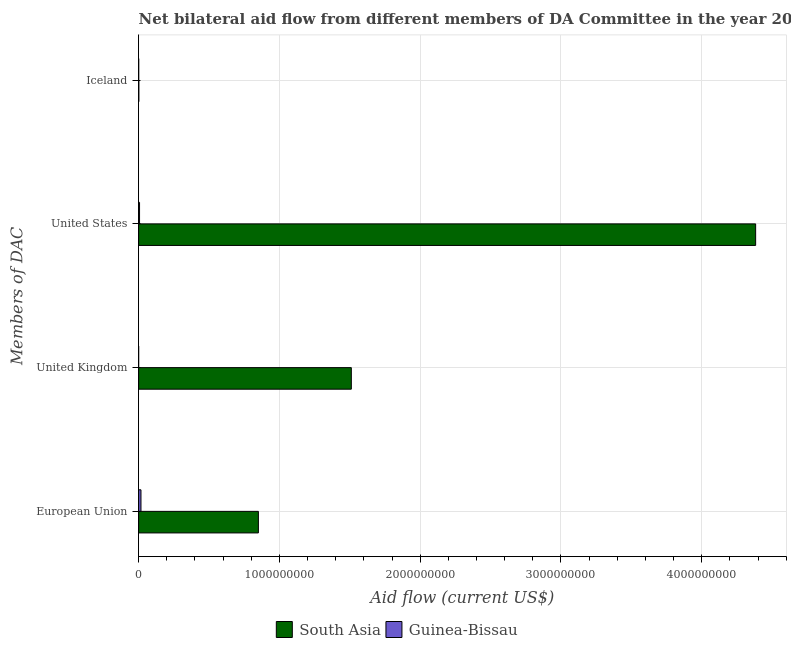How many different coloured bars are there?
Ensure brevity in your answer.  2. How many groups of bars are there?
Keep it short and to the point. 4. How many bars are there on the 1st tick from the top?
Keep it short and to the point. 2. What is the amount of aid given by us in South Asia?
Your answer should be compact. 4.38e+09. Across all countries, what is the maximum amount of aid given by eu?
Keep it short and to the point. 8.51e+08. Across all countries, what is the minimum amount of aid given by eu?
Offer a very short reply. 1.66e+07. In which country was the amount of aid given by iceland maximum?
Your response must be concise. South Asia. In which country was the amount of aid given by uk minimum?
Ensure brevity in your answer.  Guinea-Bissau. What is the total amount of aid given by us in the graph?
Keep it short and to the point. 4.39e+09. What is the difference between the amount of aid given by us in South Asia and that in Guinea-Bissau?
Ensure brevity in your answer.  4.38e+09. What is the difference between the amount of aid given by eu in South Asia and the amount of aid given by us in Guinea-Bissau?
Provide a short and direct response. 8.44e+08. What is the average amount of aid given by iceland per country?
Ensure brevity in your answer.  1.05e+06. What is the difference between the amount of aid given by us and amount of aid given by uk in South Asia?
Give a very brief answer. 2.87e+09. What is the ratio of the amount of aid given by iceland in Guinea-Bissau to that in South Asia?
Ensure brevity in your answer.  0.34. Is the amount of aid given by uk in Guinea-Bissau less than that in South Asia?
Ensure brevity in your answer.  Yes. Is the difference between the amount of aid given by iceland in South Asia and Guinea-Bissau greater than the difference between the amount of aid given by us in South Asia and Guinea-Bissau?
Give a very brief answer. No. What is the difference between the highest and the second highest amount of aid given by eu?
Your answer should be very brief. 8.34e+08. What is the difference between the highest and the lowest amount of aid given by uk?
Ensure brevity in your answer.  1.51e+09. In how many countries, is the amount of aid given by iceland greater than the average amount of aid given by iceland taken over all countries?
Offer a terse response. 1. Is the sum of the amount of aid given by uk in Guinea-Bissau and South Asia greater than the maximum amount of aid given by iceland across all countries?
Your response must be concise. Yes. Is it the case that in every country, the sum of the amount of aid given by eu and amount of aid given by iceland is greater than the sum of amount of aid given by uk and amount of aid given by us?
Your answer should be very brief. No. What does the 1st bar from the top in Iceland represents?
Make the answer very short. Guinea-Bissau. How many countries are there in the graph?
Give a very brief answer. 2. How are the legend labels stacked?
Your answer should be compact. Horizontal. What is the title of the graph?
Provide a succinct answer. Net bilateral aid flow from different members of DA Committee in the year 2010. What is the label or title of the X-axis?
Your response must be concise. Aid flow (current US$). What is the label or title of the Y-axis?
Provide a short and direct response. Members of DAC. What is the Aid flow (current US$) of South Asia in European Union?
Your answer should be compact. 8.51e+08. What is the Aid flow (current US$) in Guinea-Bissau in European Union?
Offer a terse response. 1.66e+07. What is the Aid flow (current US$) of South Asia in United Kingdom?
Make the answer very short. 1.51e+09. What is the Aid flow (current US$) in Guinea-Bissau in United Kingdom?
Your answer should be very brief. 7.00e+04. What is the Aid flow (current US$) of South Asia in United States?
Give a very brief answer. 4.38e+09. What is the Aid flow (current US$) of Guinea-Bissau in United States?
Your answer should be compact. 6.52e+06. What is the Aid flow (current US$) of South Asia in Iceland?
Your answer should be compact. 1.57e+06. What is the Aid flow (current US$) of Guinea-Bissau in Iceland?
Give a very brief answer. 5.30e+05. Across all Members of DAC, what is the maximum Aid flow (current US$) of South Asia?
Ensure brevity in your answer.  4.38e+09. Across all Members of DAC, what is the maximum Aid flow (current US$) of Guinea-Bissau?
Provide a succinct answer. 1.66e+07. Across all Members of DAC, what is the minimum Aid flow (current US$) of South Asia?
Give a very brief answer. 1.57e+06. Across all Members of DAC, what is the minimum Aid flow (current US$) in Guinea-Bissau?
Provide a succinct answer. 7.00e+04. What is the total Aid flow (current US$) of South Asia in the graph?
Your answer should be compact. 6.75e+09. What is the total Aid flow (current US$) in Guinea-Bissau in the graph?
Provide a short and direct response. 2.37e+07. What is the difference between the Aid flow (current US$) in South Asia in European Union and that in United Kingdom?
Offer a terse response. -6.60e+08. What is the difference between the Aid flow (current US$) in Guinea-Bissau in European Union and that in United Kingdom?
Provide a short and direct response. 1.65e+07. What is the difference between the Aid flow (current US$) of South Asia in European Union and that in United States?
Provide a succinct answer. -3.53e+09. What is the difference between the Aid flow (current US$) of Guinea-Bissau in European Union and that in United States?
Give a very brief answer. 1.00e+07. What is the difference between the Aid flow (current US$) in South Asia in European Union and that in Iceland?
Keep it short and to the point. 8.49e+08. What is the difference between the Aid flow (current US$) in Guinea-Bissau in European Union and that in Iceland?
Keep it short and to the point. 1.60e+07. What is the difference between the Aid flow (current US$) in South Asia in United Kingdom and that in United States?
Give a very brief answer. -2.87e+09. What is the difference between the Aid flow (current US$) of Guinea-Bissau in United Kingdom and that in United States?
Ensure brevity in your answer.  -6.45e+06. What is the difference between the Aid flow (current US$) of South Asia in United Kingdom and that in Iceland?
Provide a short and direct response. 1.51e+09. What is the difference between the Aid flow (current US$) in Guinea-Bissau in United Kingdom and that in Iceland?
Your answer should be compact. -4.60e+05. What is the difference between the Aid flow (current US$) of South Asia in United States and that in Iceland?
Provide a succinct answer. 4.38e+09. What is the difference between the Aid flow (current US$) in Guinea-Bissau in United States and that in Iceland?
Your answer should be very brief. 5.99e+06. What is the difference between the Aid flow (current US$) of South Asia in European Union and the Aid flow (current US$) of Guinea-Bissau in United Kingdom?
Your answer should be compact. 8.51e+08. What is the difference between the Aid flow (current US$) in South Asia in European Union and the Aid flow (current US$) in Guinea-Bissau in United States?
Keep it short and to the point. 8.44e+08. What is the difference between the Aid flow (current US$) of South Asia in European Union and the Aid flow (current US$) of Guinea-Bissau in Iceland?
Your answer should be compact. 8.50e+08. What is the difference between the Aid flow (current US$) of South Asia in United Kingdom and the Aid flow (current US$) of Guinea-Bissau in United States?
Ensure brevity in your answer.  1.50e+09. What is the difference between the Aid flow (current US$) in South Asia in United Kingdom and the Aid flow (current US$) in Guinea-Bissau in Iceland?
Your answer should be compact. 1.51e+09. What is the difference between the Aid flow (current US$) of South Asia in United States and the Aid flow (current US$) of Guinea-Bissau in Iceland?
Your response must be concise. 4.38e+09. What is the average Aid flow (current US$) in South Asia per Members of DAC?
Keep it short and to the point. 1.69e+09. What is the average Aid flow (current US$) of Guinea-Bissau per Members of DAC?
Give a very brief answer. 5.92e+06. What is the difference between the Aid flow (current US$) of South Asia and Aid flow (current US$) of Guinea-Bissau in European Union?
Ensure brevity in your answer.  8.34e+08. What is the difference between the Aid flow (current US$) of South Asia and Aid flow (current US$) of Guinea-Bissau in United Kingdom?
Make the answer very short. 1.51e+09. What is the difference between the Aid flow (current US$) in South Asia and Aid flow (current US$) in Guinea-Bissau in United States?
Offer a terse response. 4.38e+09. What is the difference between the Aid flow (current US$) of South Asia and Aid flow (current US$) of Guinea-Bissau in Iceland?
Your answer should be very brief. 1.04e+06. What is the ratio of the Aid flow (current US$) in South Asia in European Union to that in United Kingdom?
Your response must be concise. 0.56. What is the ratio of the Aid flow (current US$) of Guinea-Bissau in European Union to that in United Kingdom?
Provide a short and direct response. 236.71. What is the ratio of the Aid flow (current US$) in South Asia in European Union to that in United States?
Your response must be concise. 0.19. What is the ratio of the Aid flow (current US$) in Guinea-Bissau in European Union to that in United States?
Provide a short and direct response. 2.54. What is the ratio of the Aid flow (current US$) of South Asia in European Union to that in Iceland?
Offer a very short reply. 541.85. What is the ratio of the Aid flow (current US$) of Guinea-Bissau in European Union to that in Iceland?
Your response must be concise. 31.26. What is the ratio of the Aid flow (current US$) in South Asia in United Kingdom to that in United States?
Give a very brief answer. 0.34. What is the ratio of the Aid flow (current US$) in Guinea-Bissau in United Kingdom to that in United States?
Ensure brevity in your answer.  0.01. What is the ratio of the Aid flow (current US$) of South Asia in United Kingdom to that in Iceland?
Offer a terse response. 962.35. What is the ratio of the Aid flow (current US$) of Guinea-Bissau in United Kingdom to that in Iceland?
Your answer should be compact. 0.13. What is the ratio of the Aid flow (current US$) of South Asia in United States to that in Iceland?
Your response must be concise. 2791.71. What is the ratio of the Aid flow (current US$) in Guinea-Bissau in United States to that in Iceland?
Provide a succinct answer. 12.3. What is the difference between the highest and the second highest Aid flow (current US$) of South Asia?
Provide a succinct answer. 2.87e+09. What is the difference between the highest and the second highest Aid flow (current US$) in Guinea-Bissau?
Give a very brief answer. 1.00e+07. What is the difference between the highest and the lowest Aid flow (current US$) of South Asia?
Offer a very short reply. 4.38e+09. What is the difference between the highest and the lowest Aid flow (current US$) in Guinea-Bissau?
Your answer should be compact. 1.65e+07. 